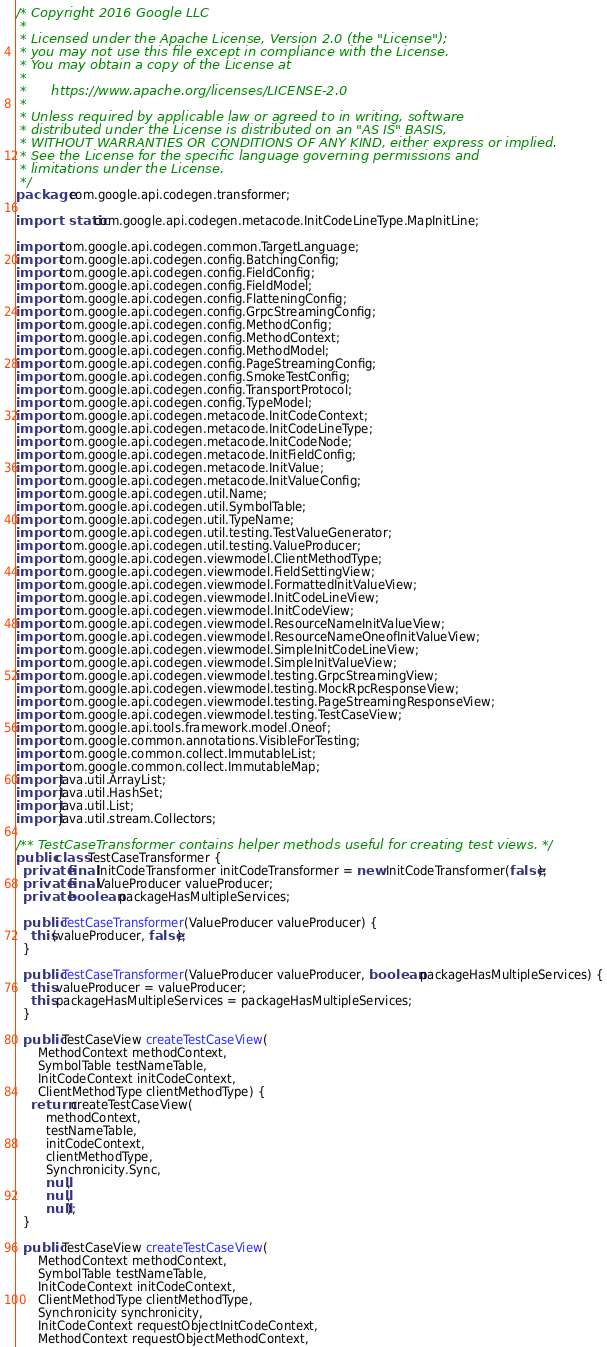Convert code to text. <code><loc_0><loc_0><loc_500><loc_500><_Java_>/* Copyright 2016 Google LLC
 *
 * Licensed under the Apache License, Version 2.0 (the "License");
 * you may not use this file except in compliance with the License.
 * You may obtain a copy of the License at
 *
 *      https://www.apache.org/licenses/LICENSE-2.0
 *
 * Unless required by applicable law or agreed to in writing, software
 * distributed under the License is distributed on an "AS IS" BASIS,
 * WITHOUT WARRANTIES OR CONDITIONS OF ANY KIND, either express or implied.
 * See the License for the specific language governing permissions and
 * limitations under the License.
 */
package com.google.api.codegen.transformer;

import static com.google.api.codegen.metacode.InitCodeLineType.MapInitLine;

import com.google.api.codegen.common.TargetLanguage;
import com.google.api.codegen.config.BatchingConfig;
import com.google.api.codegen.config.FieldConfig;
import com.google.api.codegen.config.FieldModel;
import com.google.api.codegen.config.FlatteningConfig;
import com.google.api.codegen.config.GrpcStreamingConfig;
import com.google.api.codegen.config.MethodConfig;
import com.google.api.codegen.config.MethodContext;
import com.google.api.codegen.config.MethodModel;
import com.google.api.codegen.config.PageStreamingConfig;
import com.google.api.codegen.config.SmokeTestConfig;
import com.google.api.codegen.config.TransportProtocol;
import com.google.api.codegen.config.TypeModel;
import com.google.api.codegen.metacode.InitCodeContext;
import com.google.api.codegen.metacode.InitCodeLineType;
import com.google.api.codegen.metacode.InitCodeNode;
import com.google.api.codegen.metacode.InitFieldConfig;
import com.google.api.codegen.metacode.InitValue;
import com.google.api.codegen.metacode.InitValueConfig;
import com.google.api.codegen.util.Name;
import com.google.api.codegen.util.SymbolTable;
import com.google.api.codegen.util.TypeName;
import com.google.api.codegen.util.testing.TestValueGenerator;
import com.google.api.codegen.util.testing.ValueProducer;
import com.google.api.codegen.viewmodel.ClientMethodType;
import com.google.api.codegen.viewmodel.FieldSettingView;
import com.google.api.codegen.viewmodel.FormattedInitValueView;
import com.google.api.codegen.viewmodel.InitCodeLineView;
import com.google.api.codegen.viewmodel.InitCodeView;
import com.google.api.codegen.viewmodel.ResourceNameInitValueView;
import com.google.api.codegen.viewmodel.ResourceNameOneofInitValueView;
import com.google.api.codegen.viewmodel.SimpleInitCodeLineView;
import com.google.api.codegen.viewmodel.SimpleInitValueView;
import com.google.api.codegen.viewmodel.testing.GrpcStreamingView;
import com.google.api.codegen.viewmodel.testing.MockRpcResponseView;
import com.google.api.codegen.viewmodel.testing.PageStreamingResponseView;
import com.google.api.codegen.viewmodel.testing.TestCaseView;
import com.google.api.tools.framework.model.Oneof;
import com.google.common.annotations.VisibleForTesting;
import com.google.common.collect.ImmutableList;
import com.google.common.collect.ImmutableMap;
import java.util.ArrayList;
import java.util.HashSet;
import java.util.List;
import java.util.stream.Collectors;

/** TestCaseTransformer contains helper methods useful for creating test views. */
public class TestCaseTransformer {
  private final InitCodeTransformer initCodeTransformer = new InitCodeTransformer(false);
  private final ValueProducer valueProducer;
  private boolean packageHasMultipleServices;

  public TestCaseTransformer(ValueProducer valueProducer) {
    this(valueProducer, false);
  }

  public TestCaseTransformer(ValueProducer valueProducer, boolean packageHasMultipleServices) {
    this.valueProducer = valueProducer;
    this.packageHasMultipleServices = packageHasMultipleServices;
  }

  public TestCaseView createTestCaseView(
      MethodContext methodContext,
      SymbolTable testNameTable,
      InitCodeContext initCodeContext,
      ClientMethodType clientMethodType) {
    return createTestCaseView(
        methodContext,
        testNameTable,
        initCodeContext,
        clientMethodType,
        Synchronicity.Sync,
        null,
        null,
        null);
  }

  public TestCaseView createTestCaseView(
      MethodContext methodContext,
      SymbolTable testNameTable,
      InitCodeContext initCodeContext,
      ClientMethodType clientMethodType,
      Synchronicity synchronicity,
      InitCodeContext requestObjectInitCodeContext,
      MethodContext requestObjectMethodContext,</code> 